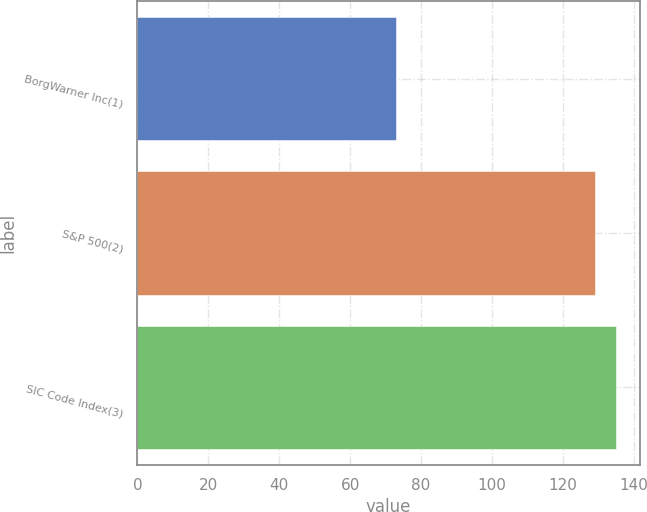Convert chart. <chart><loc_0><loc_0><loc_500><loc_500><bar_chart><fcel>BorgWarner Inc(1)<fcel>S&P 500(2)<fcel>SIC Code Index(3)<nl><fcel>73.02<fcel>129.05<fcel>134.98<nl></chart> 